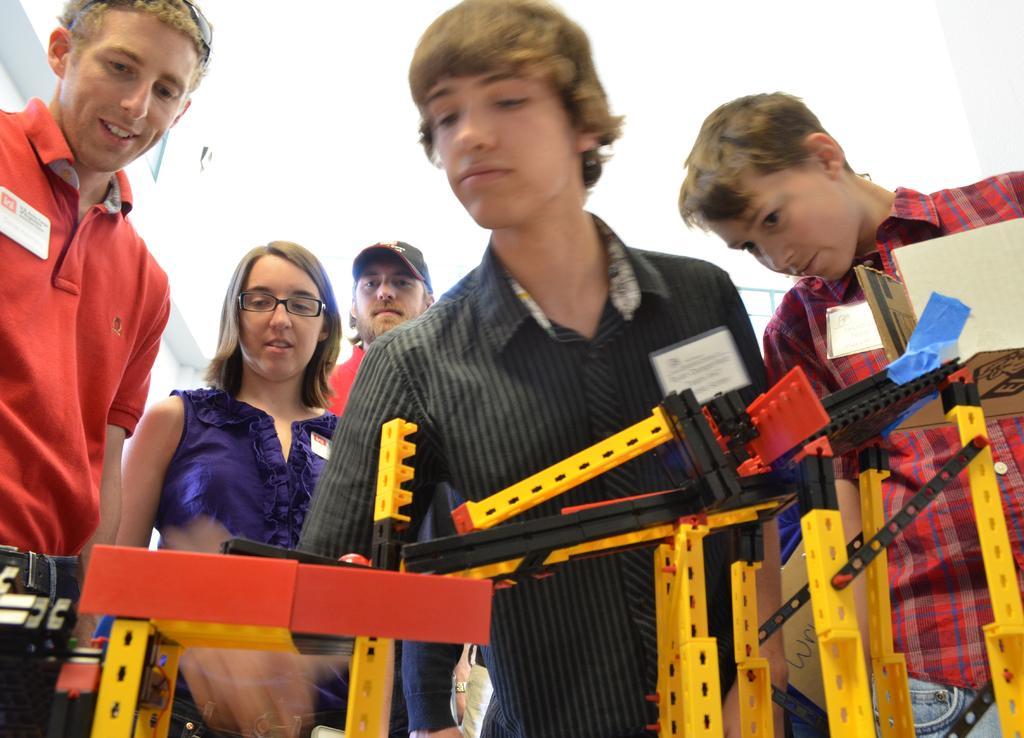Please provide a concise description of this image. In this image we can see few people and there are badges on their clothes. There are few objects at the bottom of the image. 